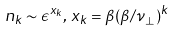<formula> <loc_0><loc_0><loc_500><loc_500>n _ { k } \sim \epsilon ^ { x _ { k } } , \, x _ { k } = \beta ( \beta / \nu _ { \perp } ) ^ { k }</formula> 